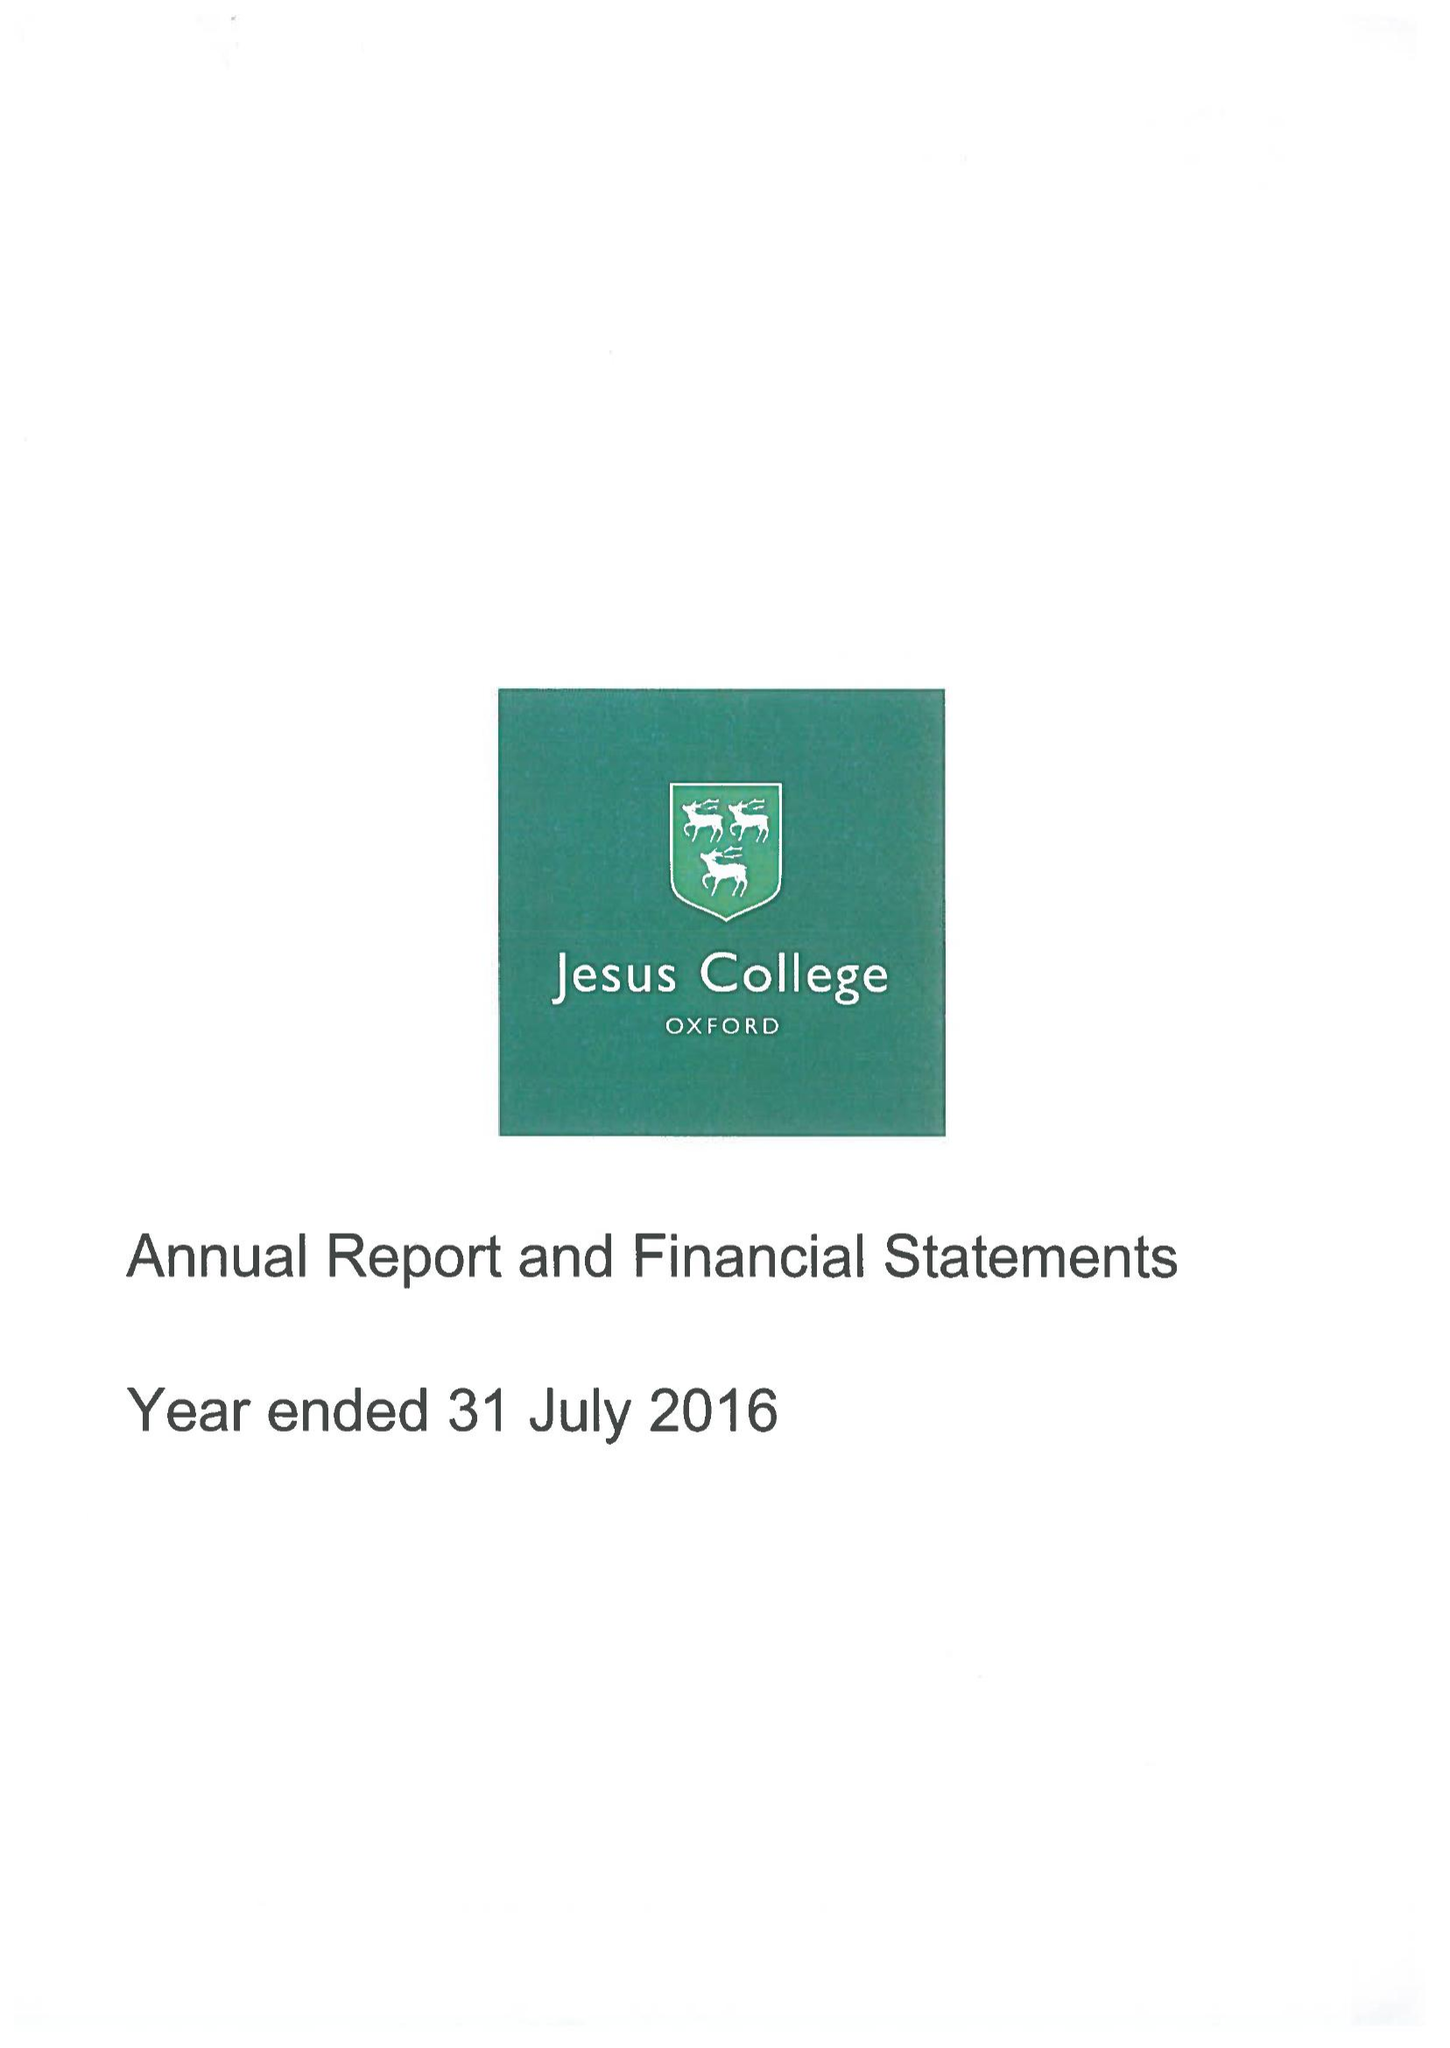What is the value for the report_date?
Answer the question using a single word or phrase. 2016-07-31 